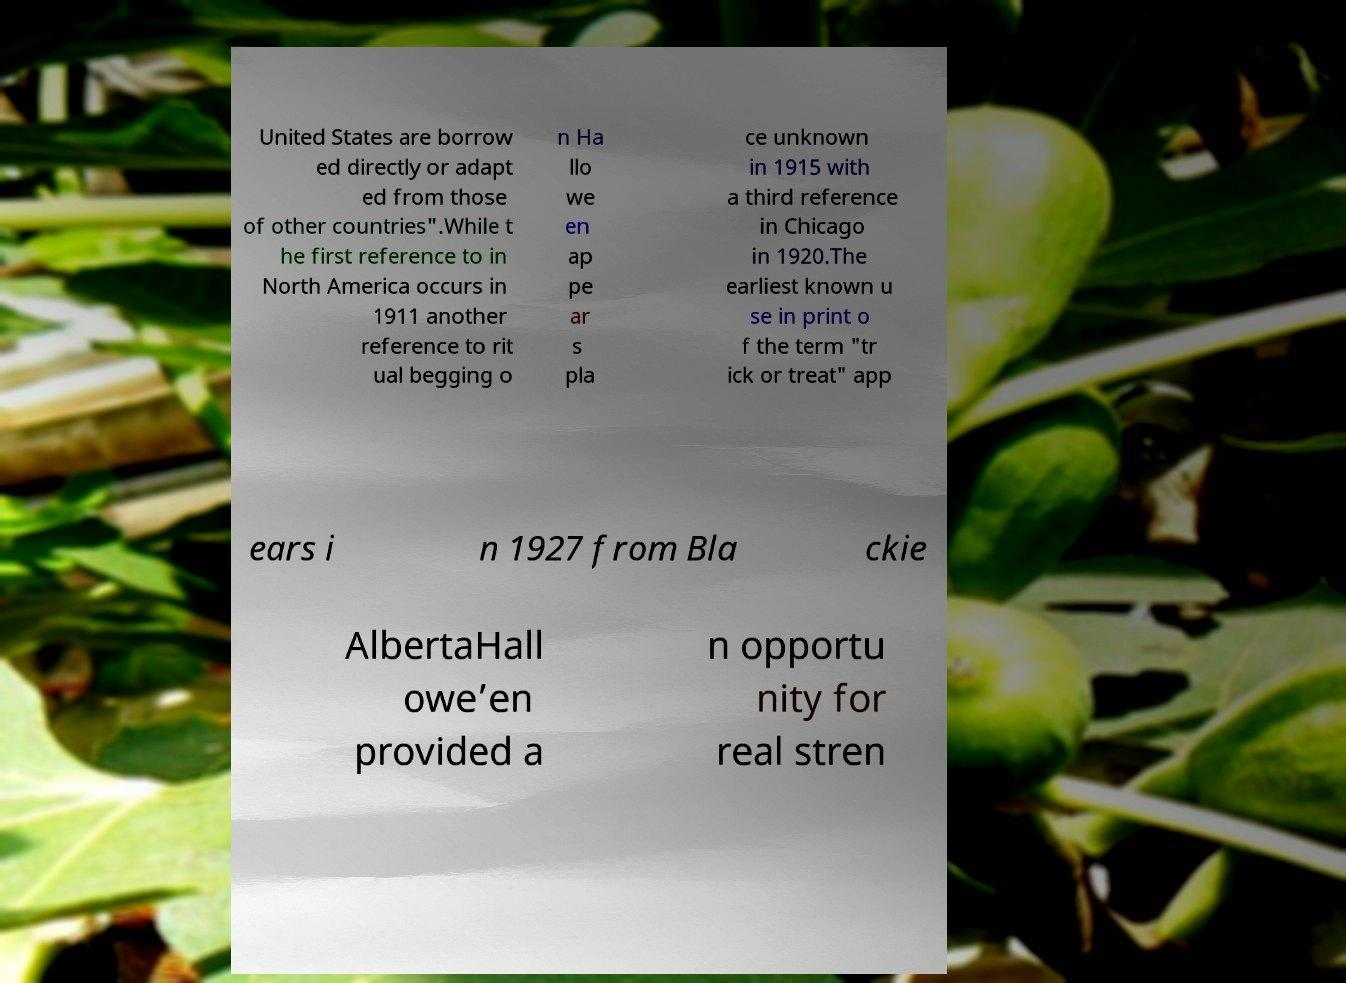For documentation purposes, I need the text within this image transcribed. Could you provide that? United States are borrow ed directly or adapt ed from those of other countries".While t he first reference to in North America occurs in 1911 another reference to rit ual begging o n Ha llo we en ap pe ar s pla ce unknown in 1915 with a third reference in Chicago in 1920.The earliest known u se in print o f the term "tr ick or treat" app ears i n 1927 from Bla ckie AlbertaHall owe’en provided a n opportu nity for real stren 